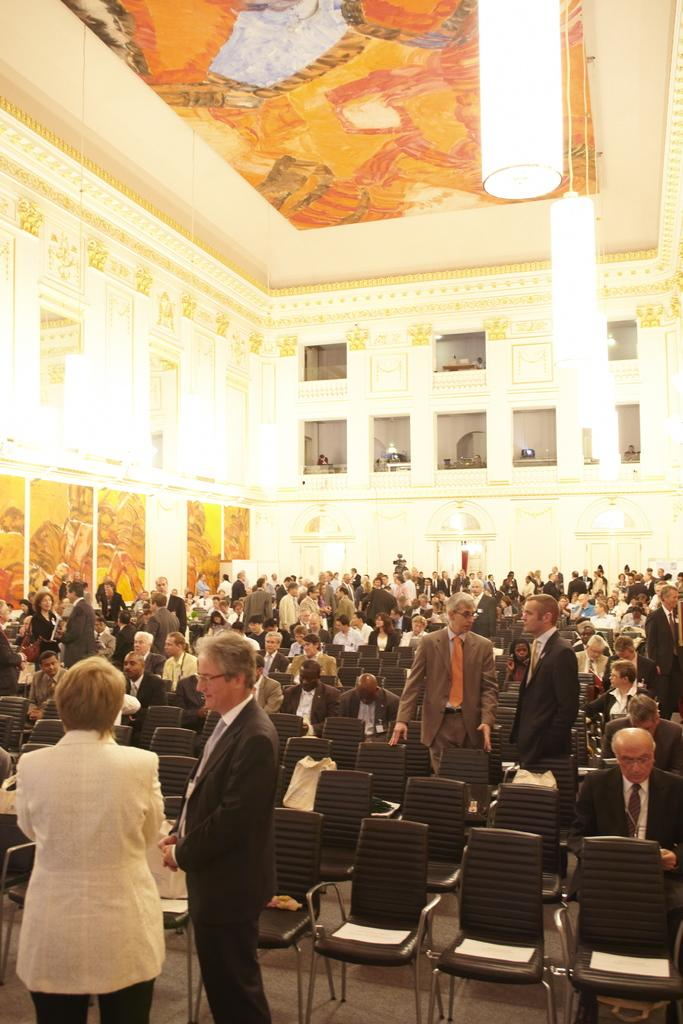What is present in the background of the image? There is a wall in the image. What are the people in the image doing? Some people are standing, while others are sitting on chairs in the image. What type of flowers can be seen growing on the wall in the image? There are no flowers visible on the wall in the image. What is the crow doing in the image? There is no crow present in the image. 